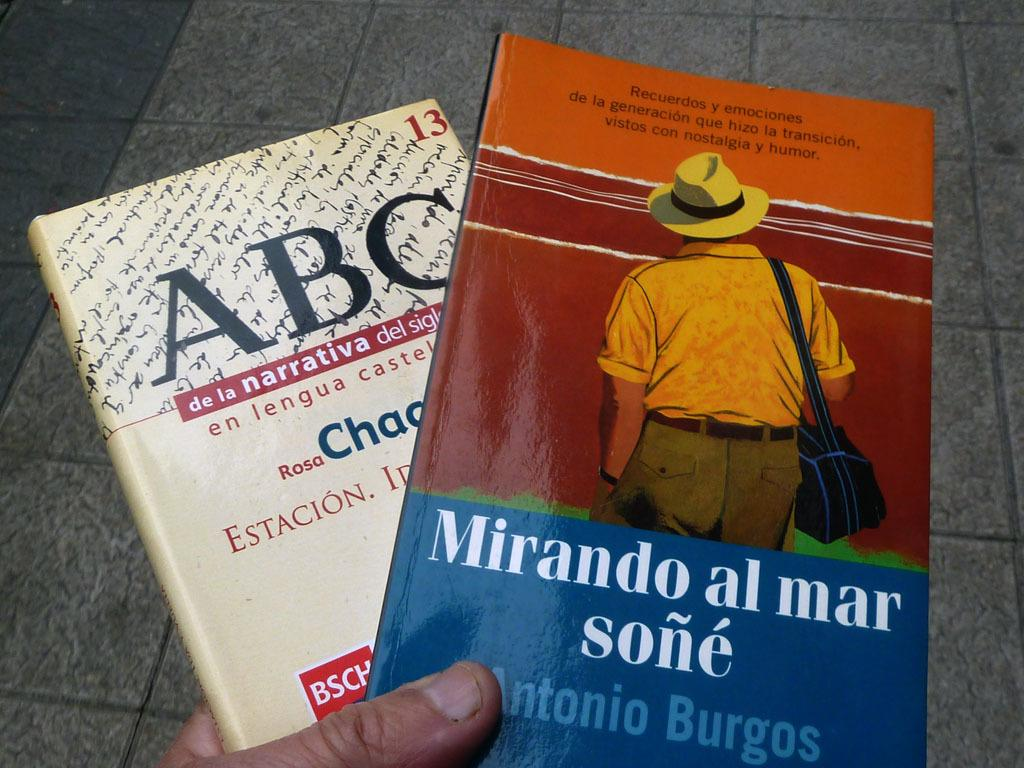<image>
Relay a brief, clear account of the picture shown. A hand is holding a book called ABC underneath a book called Mirando al mar sone 